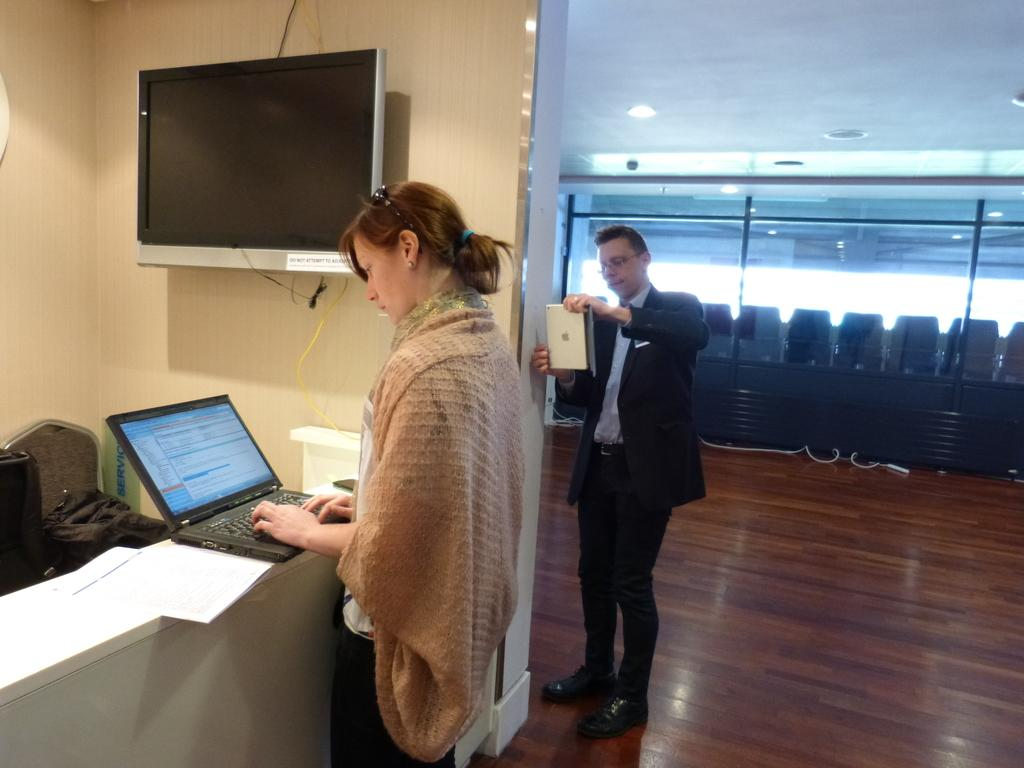What is the woman in the image doing? The woman is using a laptop. What is the man in the image doing? The man is using an Apple MacBook. What electronic device is on the wall in the image? There is a TV on the wall in the image. What type of judge is depicted in the image? There is no judge present in the image. What is the weather like outside in the image? The image does not show any outdoor scene, so it cannot be determined what the weather is like outside. Is the woman in the image driving a car? There is no indication in the image that the woman is driving a car. 